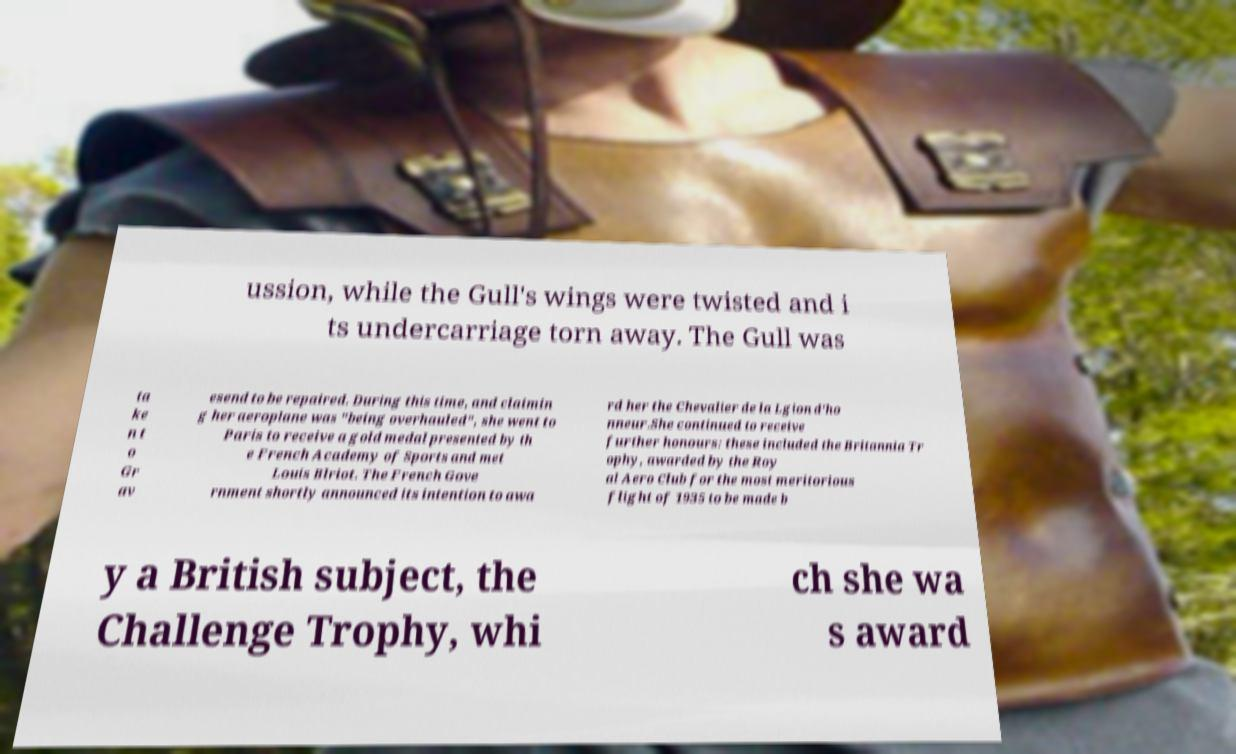For documentation purposes, I need the text within this image transcribed. Could you provide that? ussion, while the Gull's wings were twisted and i ts undercarriage torn away. The Gull was ta ke n t o Gr av esend to be repaired. During this time, and claimin g her aeroplane was "being overhauled", she went to Paris to receive a gold medal presented by th e French Academy of Sports and met Louis Blriot. The French Gove rnment shortly announced its intention to awa rd her the Chevalier de la Lgion d'ho nneur.She continued to receive further honours: these included the Britannia Tr ophy, awarded by the Roy al Aero Club for the most meritorious flight of 1935 to be made b y a British subject, the Challenge Trophy, whi ch she wa s award 